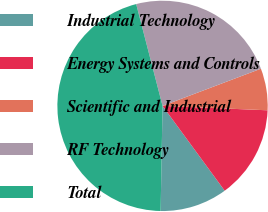<chart> <loc_0><loc_0><loc_500><loc_500><pie_chart><fcel>Industrial Technology<fcel>Energy Systems and Controls<fcel>Scientific and Industrial<fcel>RF Technology<fcel>Total<nl><fcel>10.35%<fcel>14.27%<fcel>6.42%<fcel>23.28%<fcel>45.68%<nl></chart> 